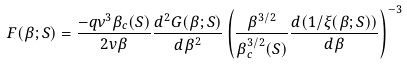Convert formula to latex. <formula><loc_0><loc_0><loc_500><loc_500>F ( \beta ; S ) = \frac { - q \nu ^ { 3 } \beta _ { c } ( S ) } { 2 v \beta } \frac { d ^ { 2 } G ( \beta ; S ) } { d \beta ^ { 2 } } \left ( \frac { \beta ^ { 3 / 2 } } { \beta ^ { 3 / 2 } _ { c } ( S ) } \frac { d ( 1 / \xi ( \beta ; S ) ) } { d \beta } \right ) ^ { - 3 }</formula> 